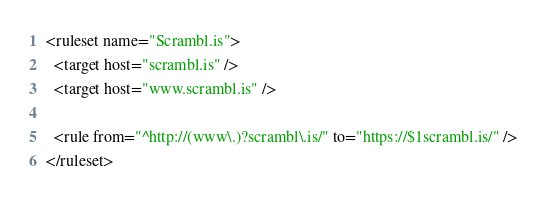Convert code to text. <code><loc_0><loc_0><loc_500><loc_500><_XML_><ruleset name="Scrambl.is">
  <target host="scrambl.is" />
  <target host="www.scrambl.is" />

  <rule from="^http://(www\.)?scrambl\.is/" to="https://$1scrambl.is/" />
</ruleset>
</code> 